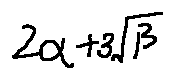Convert formula to latex. <formula><loc_0><loc_0><loc_500><loc_500>2 \alpha + 3 \sqrt { \beta }</formula> 